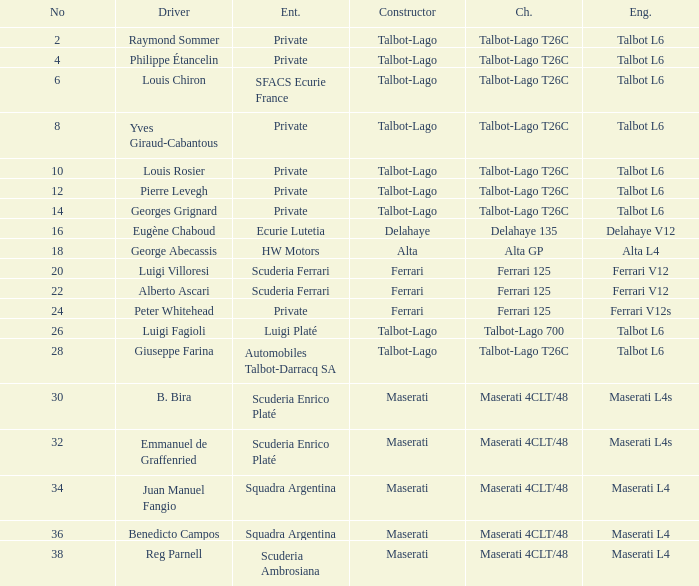Which constructor is associated with b. bira? Maserati. 